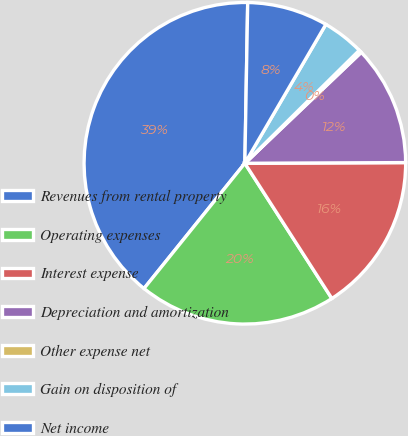<chart> <loc_0><loc_0><loc_500><loc_500><pie_chart><fcel>Revenues from rental property<fcel>Operating expenses<fcel>Interest expense<fcel>Depreciation and amortization<fcel>Other expense net<fcel>Gain on disposition of<fcel>Net income<nl><fcel>39.49%<fcel>19.89%<fcel>15.97%<fcel>12.05%<fcel>0.28%<fcel>4.2%<fcel>8.12%<nl></chart> 